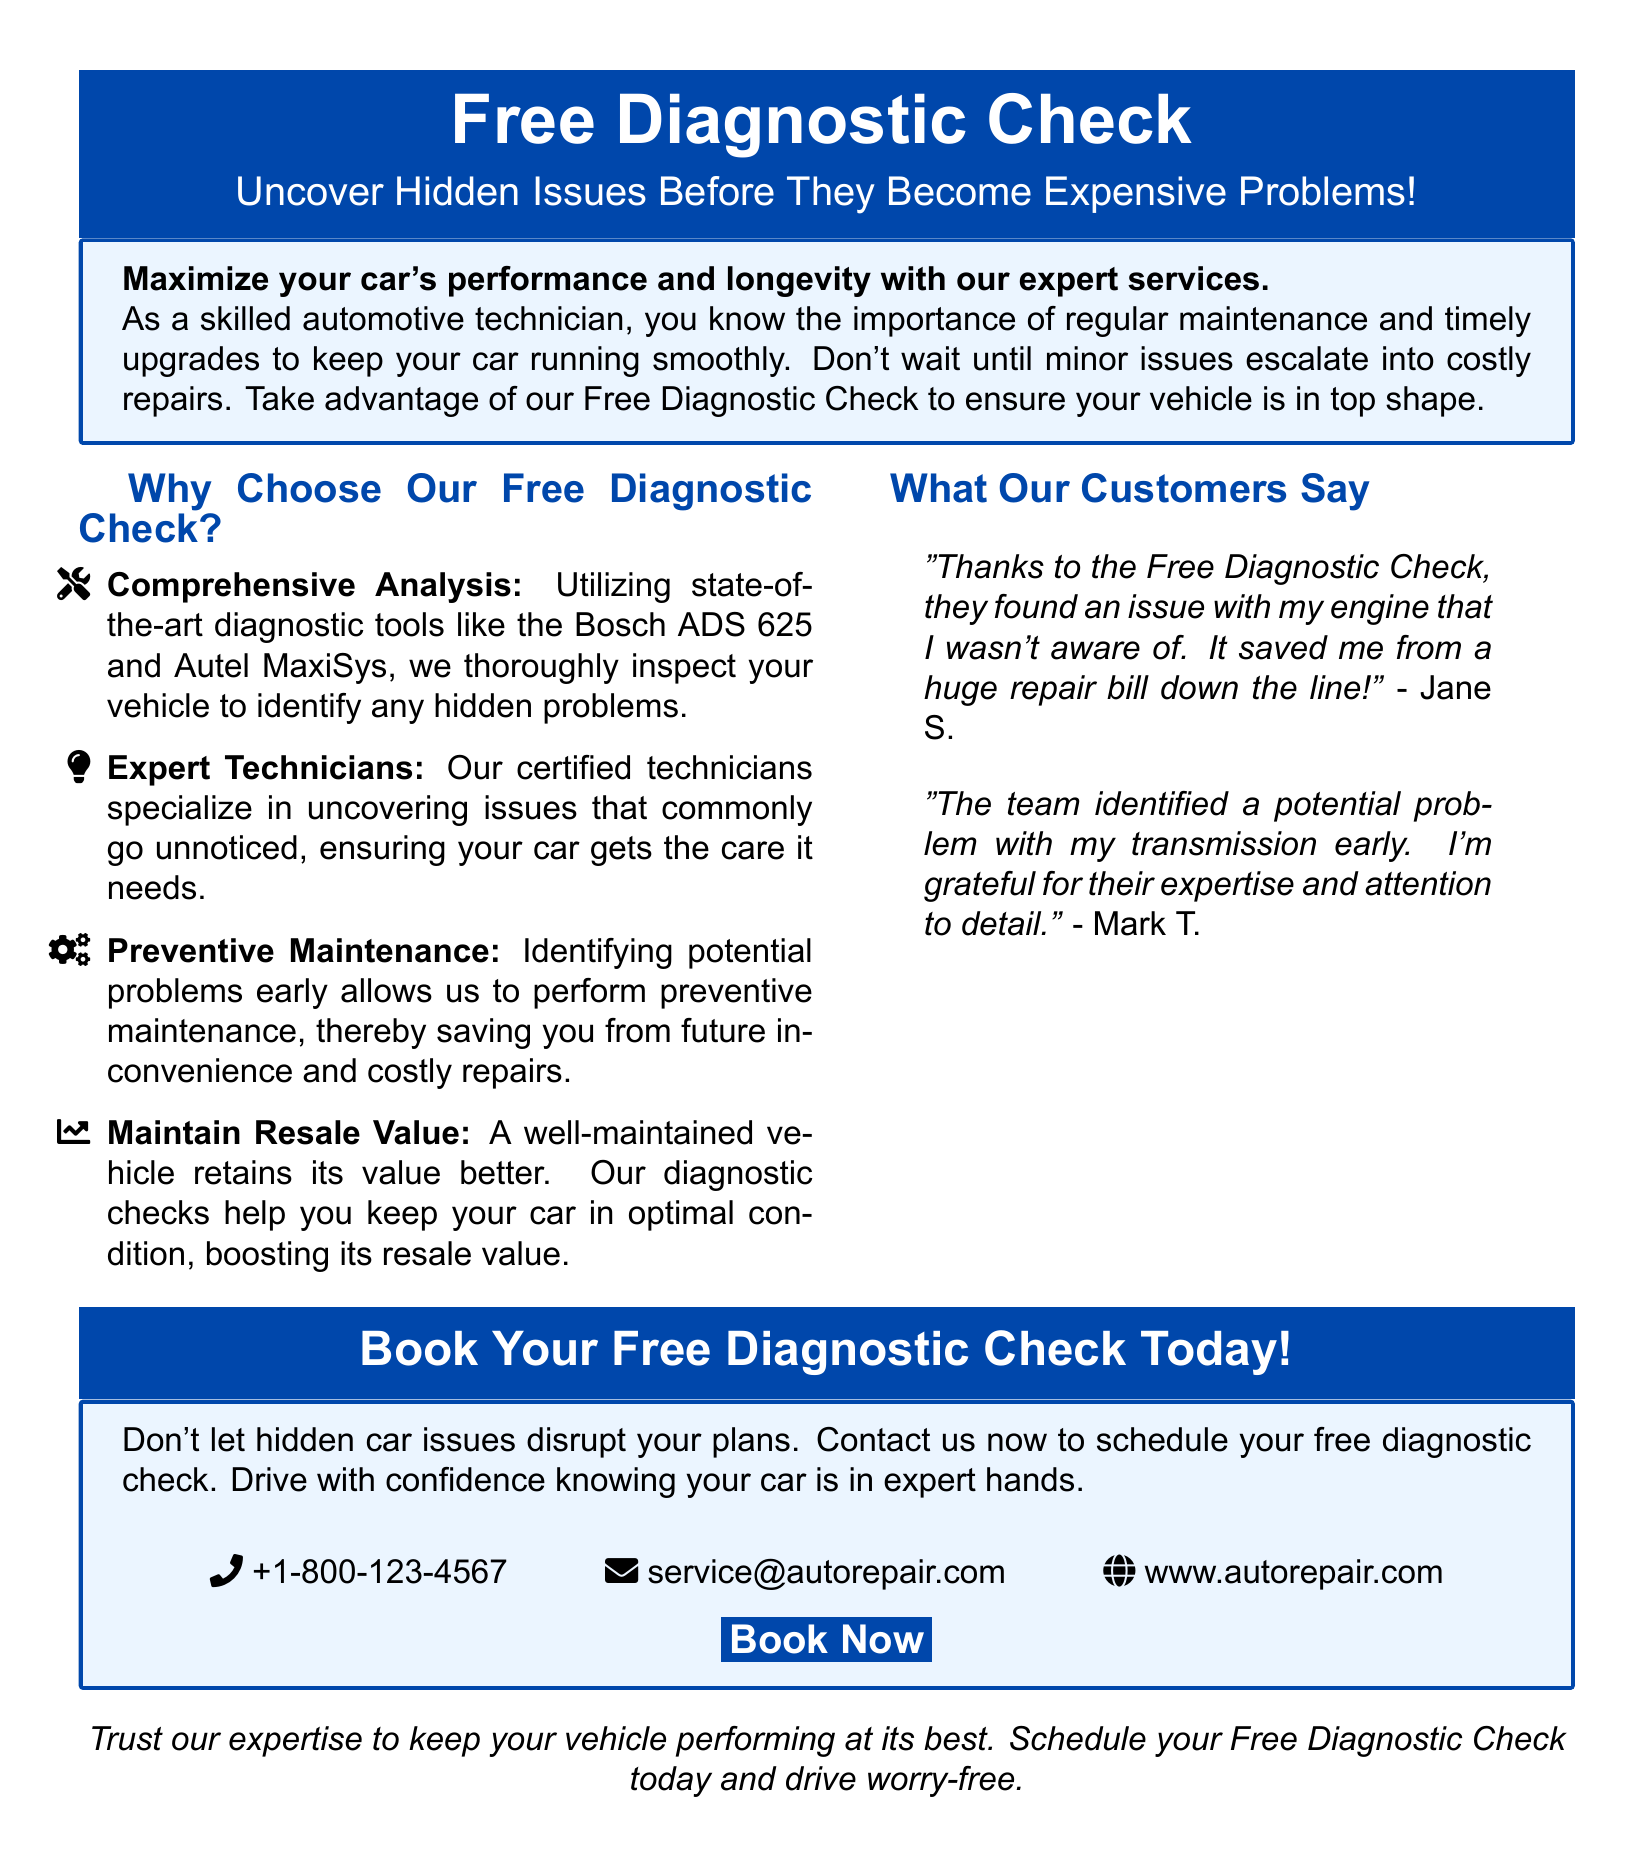what is being offered for free? The document offers a Free Diagnostic Check to customers.
Answer: Free Diagnostic Check what tools are used in the diagnostic check? The diagnostic check utilizes tools like the Bosch ADS 625 and Autel MaxiSys.
Answer: Bosch ADS 625 and Autel MaxiSys who can benefit from the service mentioned? The service is aimed at vehicle owners who want to uncover hidden issues before they become expensive problems.
Answer: Vehicle owners what feedback did a customer provide about the service? A customer named Jane S mentioned that the service saved her from a huge repair bill.
Answer: Saved from a huge repair bill what is the contact phone number for scheduling the diagnostic check? A phone number is provided in the document for scheduling: +1-800-123-4567.
Answer: +1-800-123-4567 how can the service help with resale value? The diagnostic check helps maintain the vehicle in optimal condition, boosting its resale value.
Answer: Boosting its resale value what is the color scheme used in the advertisement? The advertisement primarily uses a blue color scheme, with main blue and light blue.
Answer: Blue color scheme what should potential customers do if they want to schedule the check? Customers are encouraged to contact the service provider to schedule their free diagnostic check.
Answer: Contact us to schedule 